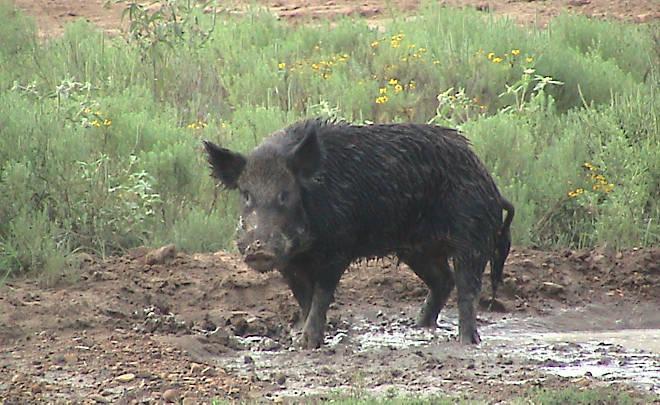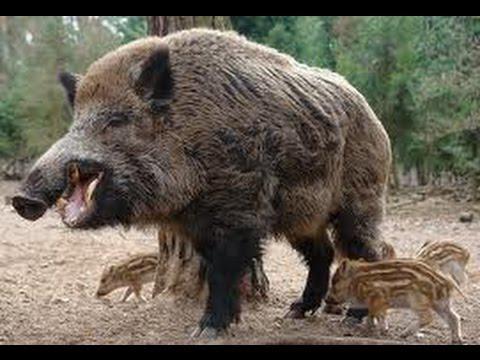The first image is the image on the left, the second image is the image on the right. For the images displayed, is the sentence "An image shows only an adult boar, and no other animals." factually correct? Answer yes or no. Yes. 